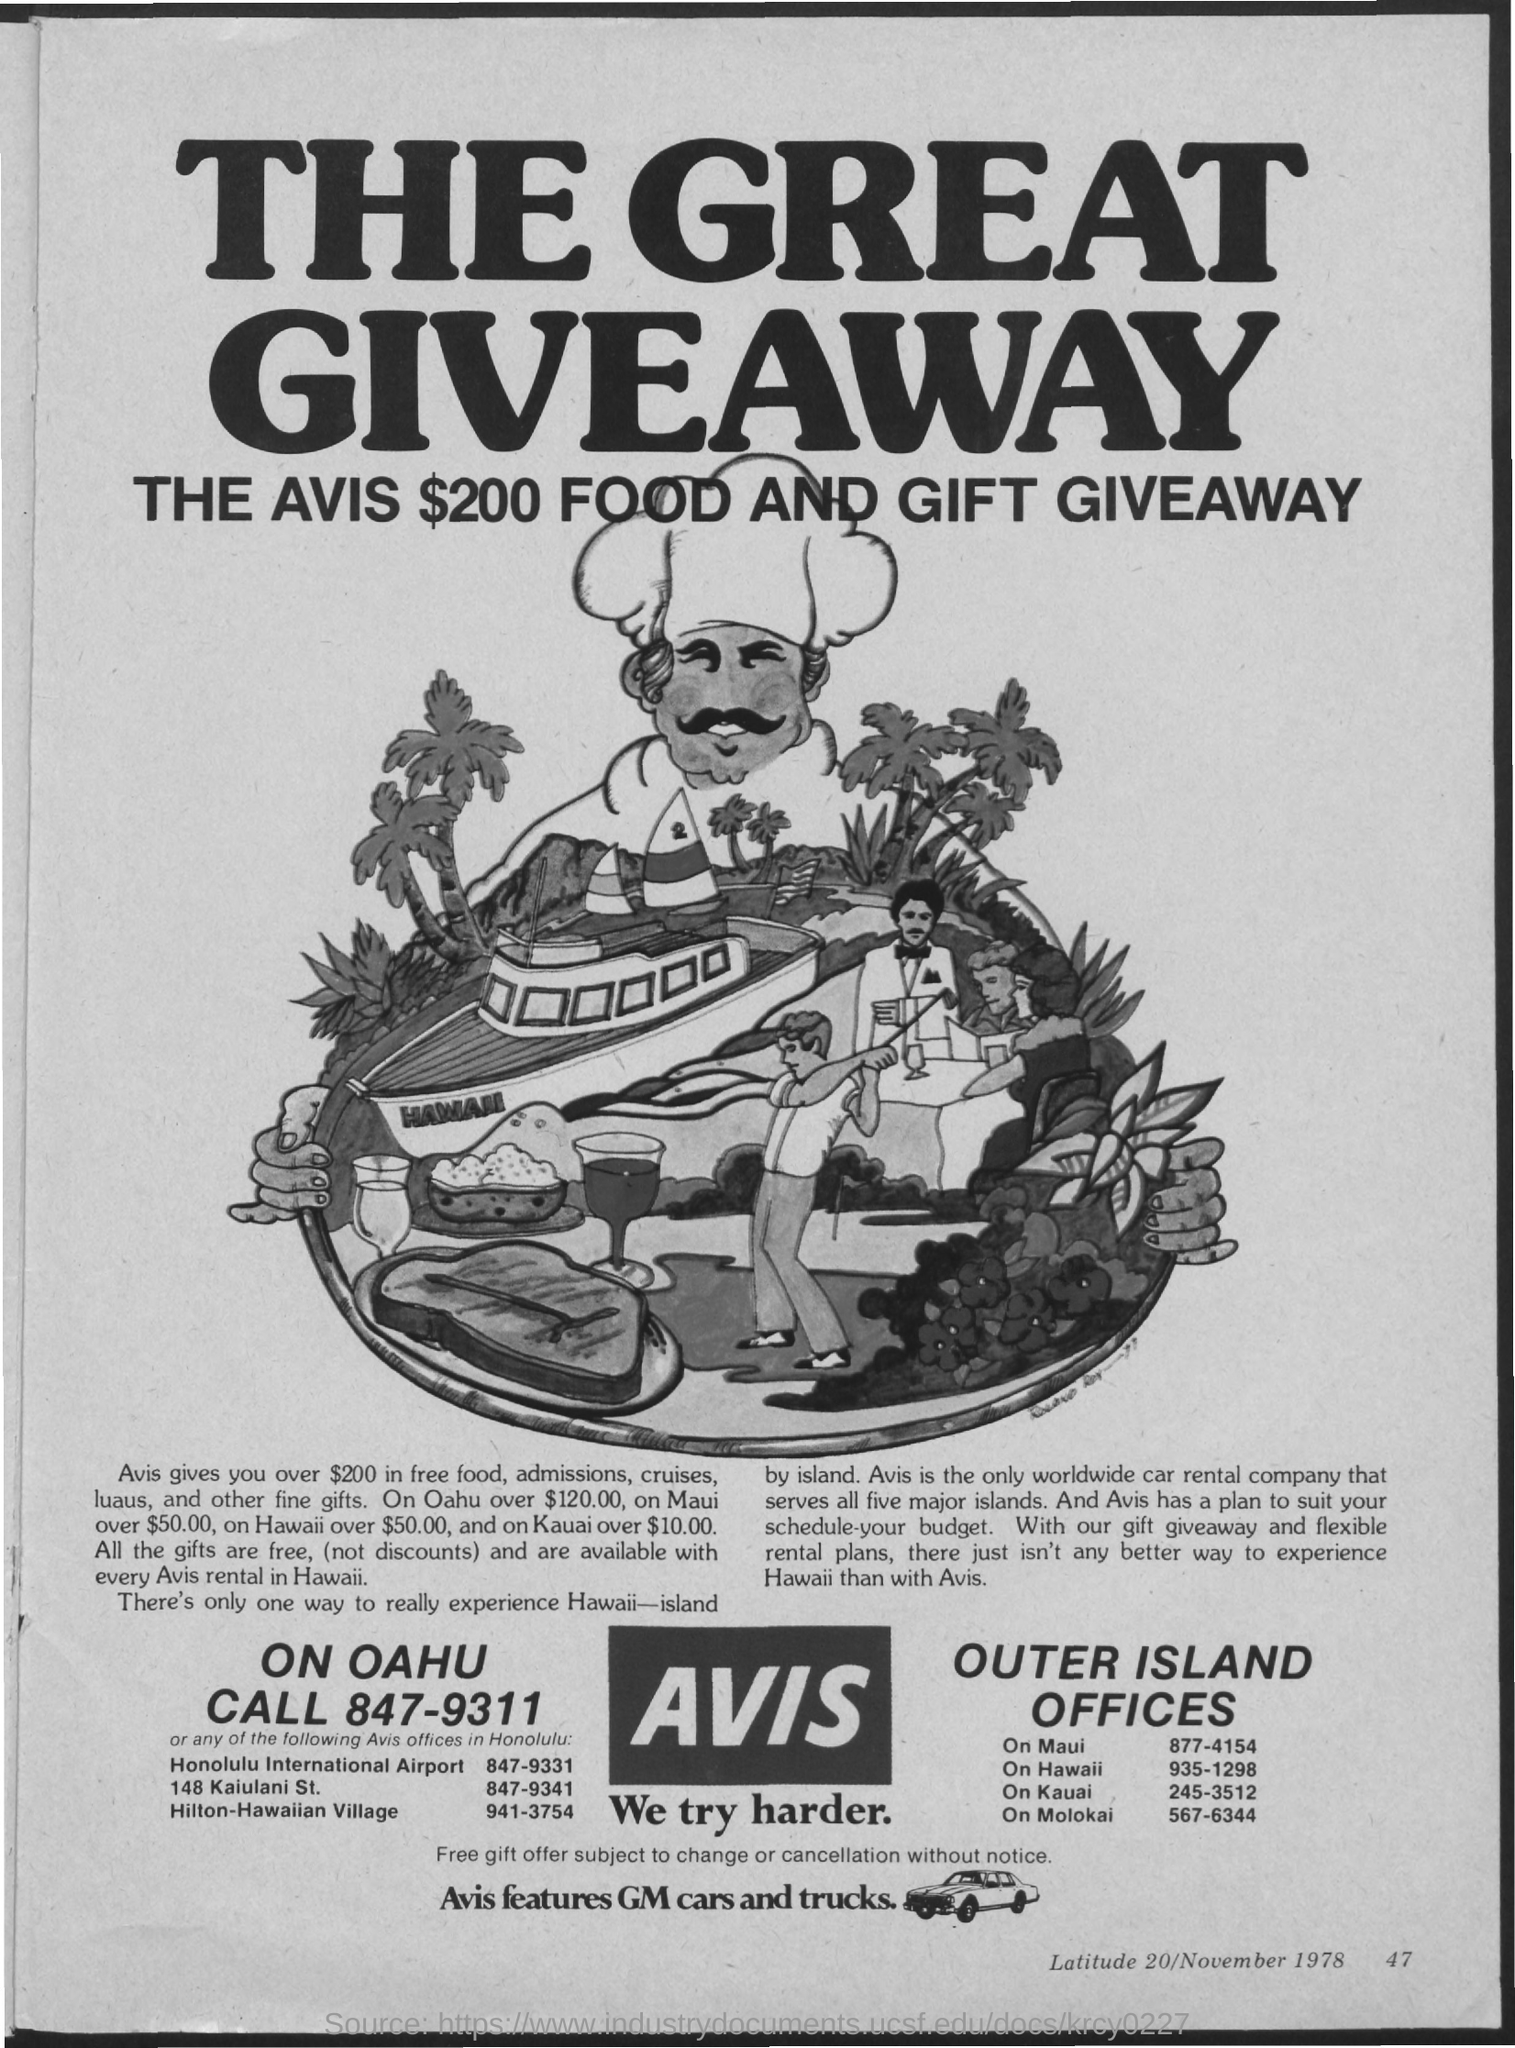What is the Title of the document?
Your response must be concise. The great giveaway. 